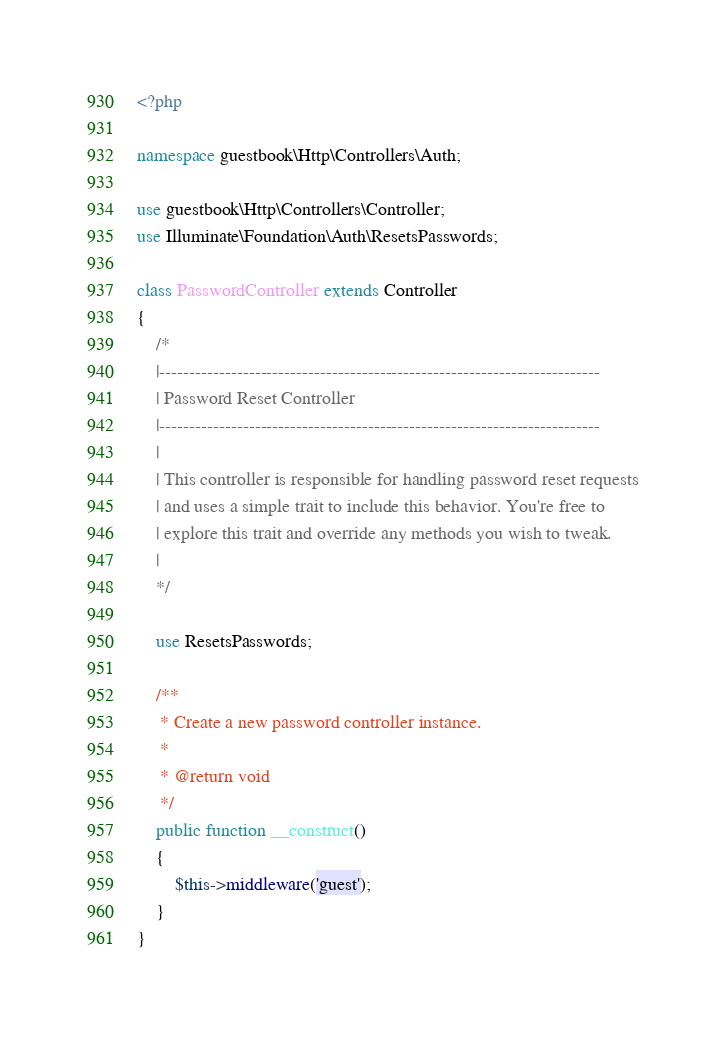Convert code to text. <code><loc_0><loc_0><loc_500><loc_500><_PHP_><?php

namespace guestbook\Http\Controllers\Auth;

use guestbook\Http\Controllers\Controller;
use Illuminate\Foundation\Auth\ResetsPasswords;

class PasswordController extends Controller
{
    /*
    |--------------------------------------------------------------------------
    | Password Reset Controller
    |--------------------------------------------------------------------------
    |
    | This controller is responsible for handling password reset requests
    | and uses a simple trait to include this behavior. You're free to
    | explore this trait and override any methods you wish to tweak.
    |
    */

    use ResetsPasswords;

    /**
     * Create a new password controller instance.
     *
     * @return void
     */
    public function __construct()
    {
        $this->middleware('guest');
    }
}
</code> 